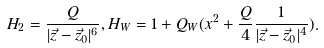Convert formula to latex. <formula><loc_0><loc_0><loc_500><loc_500>H _ { 2 } = \frac { Q } { | \vec { z } - \vec { z } _ { 0 } | ^ { 6 } } , H _ { W } = 1 + Q _ { W } ( x ^ { 2 } + \frac { Q } { 4 } \frac { 1 } { | \vec { z } - \vec { z } _ { 0 } | ^ { 4 } } ) .</formula> 